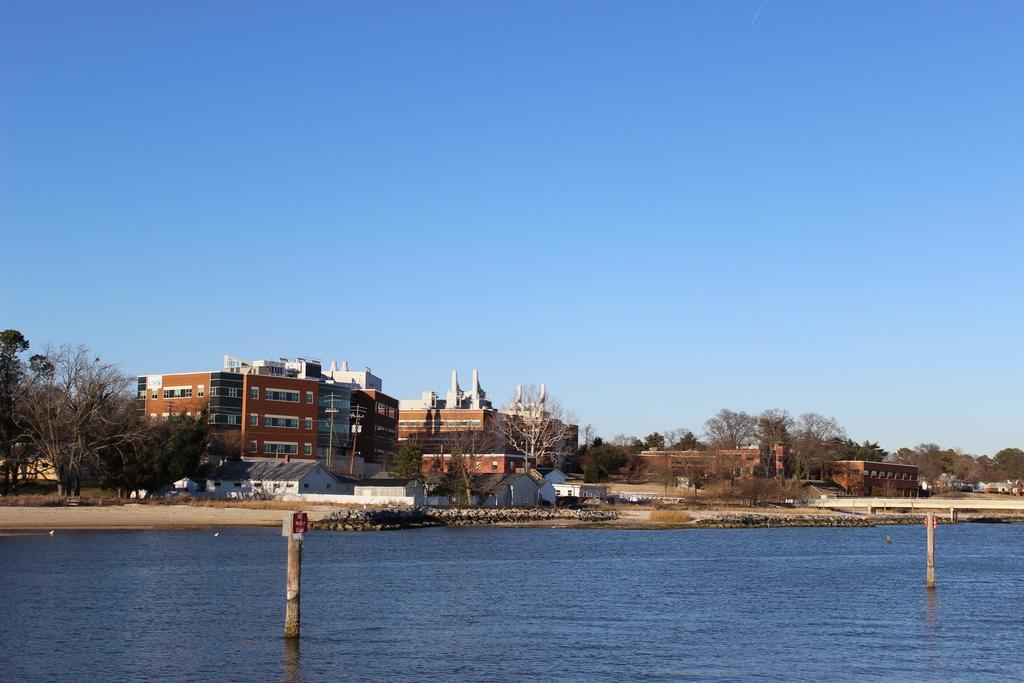In one or two sentences, can you explain what this image depicts? In the image we can see there is a river and there are trees. Behind there are buildings and there is a clear sky on the top. 